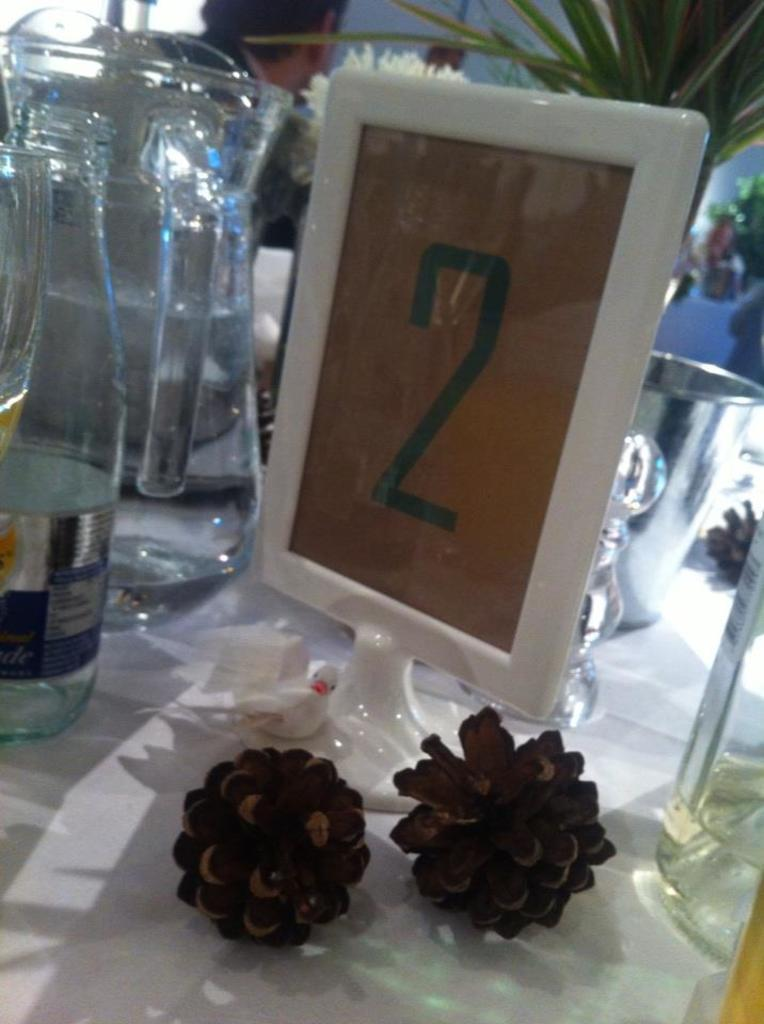What type of container is present in the image? There is a jug and a bottle in the image. Can you describe the number visible in the image? There is a number "2" on a tile in the image. What type of objects are in front of the tile? There are two flowers in front of the tile in the image. What type of neck accessory is visible in the image? There is no neck accessory present in the image. What event is taking place in the image? The image does not depict any specific event. 